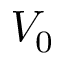Convert formula to latex. <formula><loc_0><loc_0><loc_500><loc_500>V _ { 0 }</formula> 